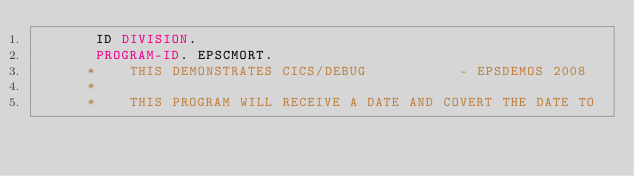<code> <loc_0><loc_0><loc_500><loc_500><_COBOL_>       ID DIVISION.
       PROGRAM-ID. EPSCMORT.
      *    THIS DEMONSTRATES CICS/DEBUG           - EPSDEMOS 2008
      *
      *    THIS PROGRAM WILL RECEIVE A DATE AND COVERT THE DATE TO</code> 